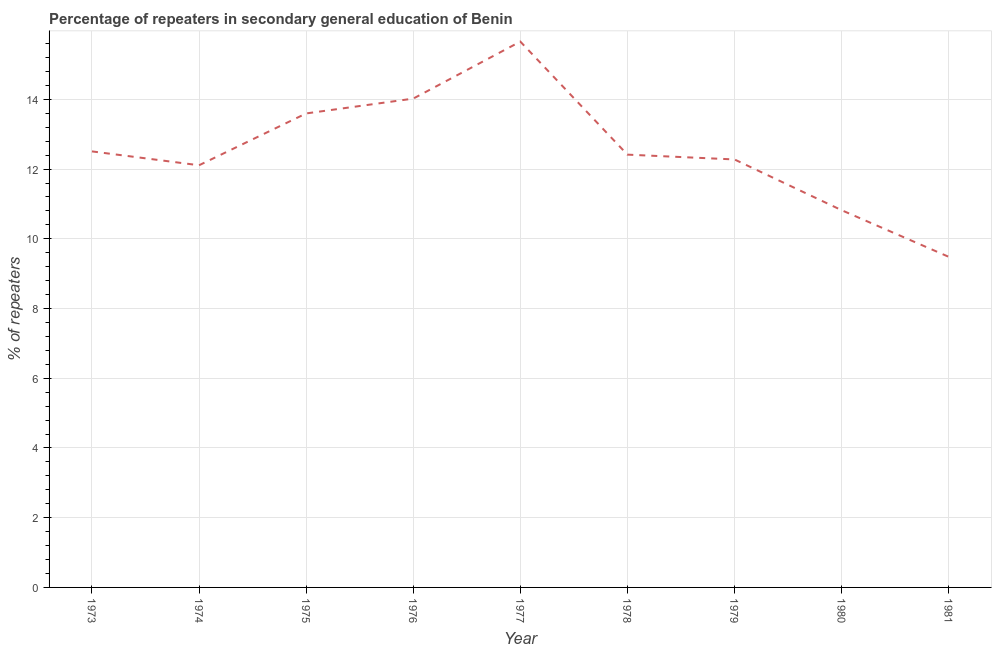What is the percentage of repeaters in 1977?
Make the answer very short. 15.66. Across all years, what is the maximum percentage of repeaters?
Offer a terse response. 15.66. Across all years, what is the minimum percentage of repeaters?
Ensure brevity in your answer.  9.48. What is the sum of the percentage of repeaters?
Provide a succinct answer. 112.88. What is the difference between the percentage of repeaters in 1974 and 1975?
Your response must be concise. -1.49. What is the average percentage of repeaters per year?
Your answer should be compact. 12.54. What is the median percentage of repeaters?
Your response must be concise. 12.41. In how many years, is the percentage of repeaters greater than 5.2 %?
Provide a succinct answer. 9. Do a majority of the years between 1977 and 1973 (inclusive) have percentage of repeaters greater than 1.2000000000000002 %?
Your answer should be compact. Yes. What is the ratio of the percentage of repeaters in 1978 to that in 1981?
Provide a succinct answer. 1.31. What is the difference between the highest and the second highest percentage of repeaters?
Offer a terse response. 1.64. What is the difference between the highest and the lowest percentage of repeaters?
Provide a short and direct response. 6.17. In how many years, is the percentage of repeaters greater than the average percentage of repeaters taken over all years?
Offer a terse response. 3. How many lines are there?
Your answer should be compact. 1. How many years are there in the graph?
Offer a terse response. 9. What is the difference between two consecutive major ticks on the Y-axis?
Your answer should be compact. 2. Does the graph contain any zero values?
Keep it short and to the point. No. Does the graph contain grids?
Give a very brief answer. Yes. What is the title of the graph?
Your answer should be very brief. Percentage of repeaters in secondary general education of Benin. What is the label or title of the Y-axis?
Give a very brief answer. % of repeaters. What is the % of repeaters of 1973?
Offer a terse response. 12.51. What is the % of repeaters of 1974?
Offer a terse response. 12.11. What is the % of repeaters in 1975?
Give a very brief answer. 13.6. What is the % of repeaters in 1976?
Your response must be concise. 14.02. What is the % of repeaters in 1977?
Provide a succinct answer. 15.66. What is the % of repeaters in 1978?
Keep it short and to the point. 12.41. What is the % of repeaters of 1979?
Your response must be concise. 12.28. What is the % of repeaters of 1980?
Your response must be concise. 10.82. What is the % of repeaters in 1981?
Offer a very short reply. 9.48. What is the difference between the % of repeaters in 1973 and 1974?
Your answer should be compact. 0.4. What is the difference between the % of repeaters in 1973 and 1975?
Offer a terse response. -1.09. What is the difference between the % of repeaters in 1973 and 1976?
Offer a terse response. -1.51. What is the difference between the % of repeaters in 1973 and 1977?
Provide a succinct answer. -3.15. What is the difference between the % of repeaters in 1973 and 1978?
Your answer should be very brief. 0.09. What is the difference between the % of repeaters in 1973 and 1979?
Offer a very short reply. 0.23. What is the difference between the % of repeaters in 1973 and 1980?
Keep it short and to the point. 1.69. What is the difference between the % of repeaters in 1973 and 1981?
Your answer should be compact. 3.02. What is the difference between the % of repeaters in 1974 and 1975?
Keep it short and to the point. -1.49. What is the difference between the % of repeaters in 1974 and 1976?
Keep it short and to the point. -1.91. What is the difference between the % of repeaters in 1974 and 1977?
Offer a very short reply. -3.55. What is the difference between the % of repeaters in 1974 and 1978?
Ensure brevity in your answer.  -0.3. What is the difference between the % of repeaters in 1974 and 1979?
Your response must be concise. -0.17. What is the difference between the % of repeaters in 1974 and 1980?
Provide a short and direct response. 1.29. What is the difference between the % of repeaters in 1974 and 1981?
Offer a terse response. 2.63. What is the difference between the % of repeaters in 1975 and 1976?
Provide a succinct answer. -0.43. What is the difference between the % of repeaters in 1975 and 1977?
Provide a short and direct response. -2.06. What is the difference between the % of repeaters in 1975 and 1978?
Provide a succinct answer. 1.18. What is the difference between the % of repeaters in 1975 and 1979?
Give a very brief answer. 1.32. What is the difference between the % of repeaters in 1975 and 1980?
Offer a terse response. 2.77. What is the difference between the % of repeaters in 1975 and 1981?
Your answer should be compact. 4.11. What is the difference between the % of repeaters in 1976 and 1977?
Provide a short and direct response. -1.64. What is the difference between the % of repeaters in 1976 and 1978?
Make the answer very short. 1.61. What is the difference between the % of repeaters in 1976 and 1979?
Ensure brevity in your answer.  1.75. What is the difference between the % of repeaters in 1976 and 1980?
Make the answer very short. 3.2. What is the difference between the % of repeaters in 1976 and 1981?
Offer a terse response. 4.54. What is the difference between the % of repeaters in 1977 and 1978?
Provide a short and direct response. 3.24. What is the difference between the % of repeaters in 1977 and 1979?
Provide a succinct answer. 3.38. What is the difference between the % of repeaters in 1977 and 1980?
Your response must be concise. 4.84. What is the difference between the % of repeaters in 1977 and 1981?
Provide a succinct answer. 6.17. What is the difference between the % of repeaters in 1978 and 1979?
Provide a succinct answer. 0.14. What is the difference between the % of repeaters in 1978 and 1980?
Offer a terse response. 1.59. What is the difference between the % of repeaters in 1978 and 1981?
Offer a terse response. 2.93. What is the difference between the % of repeaters in 1979 and 1980?
Your answer should be compact. 1.46. What is the difference between the % of repeaters in 1979 and 1981?
Provide a succinct answer. 2.79. What is the difference between the % of repeaters in 1980 and 1981?
Your answer should be very brief. 1.34. What is the ratio of the % of repeaters in 1973 to that in 1974?
Your response must be concise. 1.03. What is the ratio of the % of repeaters in 1973 to that in 1976?
Give a very brief answer. 0.89. What is the ratio of the % of repeaters in 1973 to that in 1977?
Provide a succinct answer. 0.8. What is the ratio of the % of repeaters in 1973 to that in 1978?
Ensure brevity in your answer.  1.01. What is the ratio of the % of repeaters in 1973 to that in 1980?
Provide a succinct answer. 1.16. What is the ratio of the % of repeaters in 1973 to that in 1981?
Make the answer very short. 1.32. What is the ratio of the % of repeaters in 1974 to that in 1975?
Offer a terse response. 0.89. What is the ratio of the % of repeaters in 1974 to that in 1976?
Give a very brief answer. 0.86. What is the ratio of the % of repeaters in 1974 to that in 1977?
Keep it short and to the point. 0.77. What is the ratio of the % of repeaters in 1974 to that in 1978?
Ensure brevity in your answer.  0.97. What is the ratio of the % of repeaters in 1974 to that in 1979?
Your answer should be very brief. 0.99. What is the ratio of the % of repeaters in 1974 to that in 1980?
Offer a very short reply. 1.12. What is the ratio of the % of repeaters in 1974 to that in 1981?
Offer a terse response. 1.28. What is the ratio of the % of repeaters in 1975 to that in 1977?
Keep it short and to the point. 0.87. What is the ratio of the % of repeaters in 1975 to that in 1978?
Your response must be concise. 1.09. What is the ratio of the % of repeaters in 1975 to that in 1979?
Make the answer very short. 1.11. What is the ratio of the % of repeaters in 1975 to that in 1980?
Make the answer very short. 1.26. What is the ratio of the % of repeaters in 1975 to that in 1981?
Keep it short and to the point. 1.43. What is the ratio of the % of repeaters in 1976 to that in 1977?
Make the answer very short. 0.9. What is the ratio of the % of repeaters in 1976 to that in 1978?
Provide a succinct answer. 1.13. What is the ratio of the % of repeaters in 1976 to that in 1979?
Offer a terse response. 1.14. What is the ratio of the % of repeaters in 1976 to that in 1980?
Your response must be concise. 1.3. What is the ratio of the % of repeaters in 1976 to that in 1981?
Your response must be concise. 1.48. What is the ratio of the % of repeaters in 1977 to that in 1978?
Your answer should be compact. 1.26. What is the ratio of the % of repeaters in 1977 to that in 1979?
Keep it short and to the point. 1.27. What is the ratio of the % of repeaters in 1977 to that in 1980?
Give a very brief answer. 1.45. What is the ratio of the % of repeaters in 1977 to that in 1981?
Offer a very short reply. 1.65. What is the ratio of the % of repeaters in 1978 to that in 1980?
Your response must be concise. 1.15. What is the ratio of the % of repeaters in 1978 to that in 1981?
Your answer should be very brief. 1.31. What is the ratio of the % of repeaters in 1979 to that in 1980?
Keep it short and to the point. 1.13. What is the ratio of the % of repeaters in 1979 to that in 1981?
Your response must be concise. 1.29. What is the ratio of the % of repeaters in 1980 to that in 1981?
Provide a short and direct response. 1.14. 